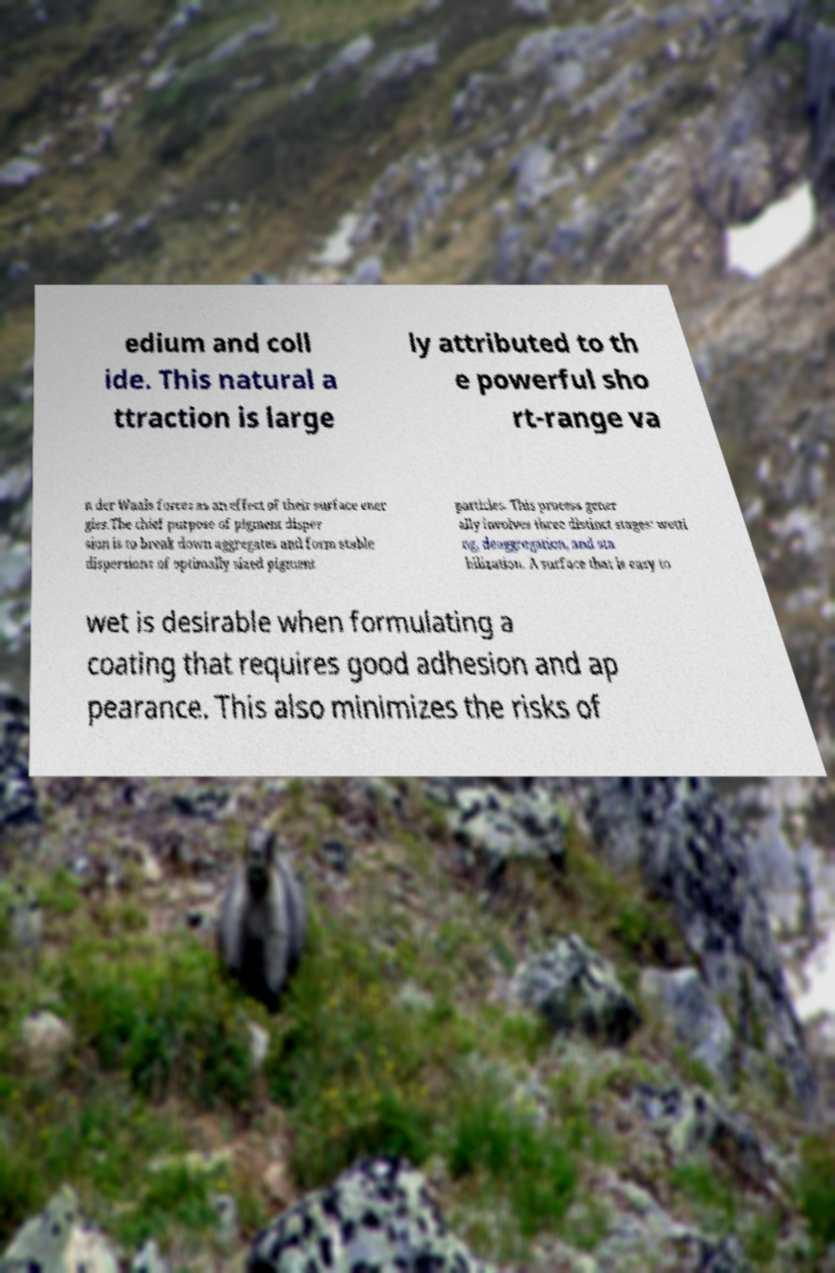There's text embedded in this image that I need extracted. Can you transcribe it verbatim? edium and coll ide. This natural a ttraction is large ly attributed to th e powerful sho rt-range va n der Waals forces as an effect of their surface ener gies.The chief purpose of pigment disper sion is to break down aggregates and form stable dispersions of optimally sized pigment particles. This process gener ally involves three distinct stages: wetti ng, deaggregation, and sta bilization. A surface that is easy to wet is desirable when formulating a coating that requires good adhesion and ap pearance. This also minimizes the risks of 